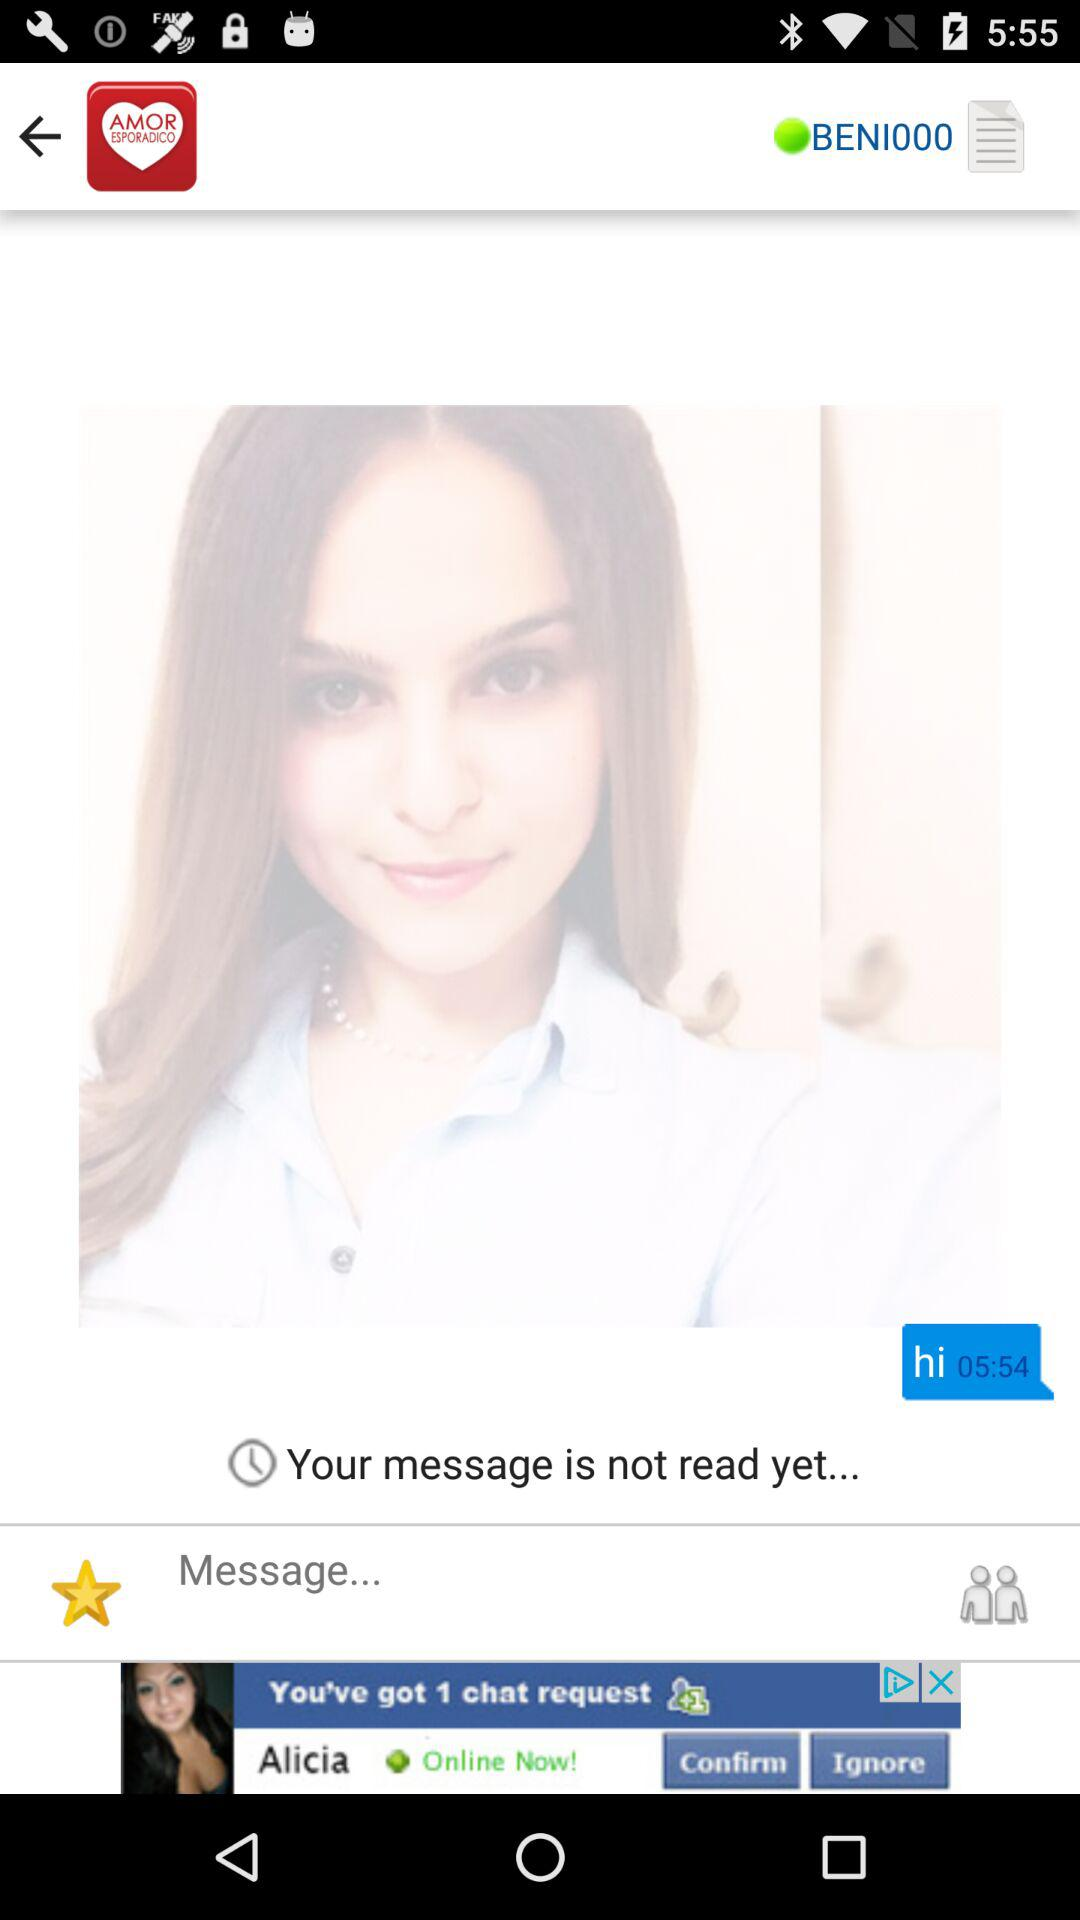What is the status of the user? The user is online. 